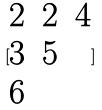<formula> <loc_0><loc_0><loc_500><loc_500>[ \begin{matrix} 2 & 2 & 4 \\ 3 & 5 \\ 6 \end{matrix} ]</formula> 